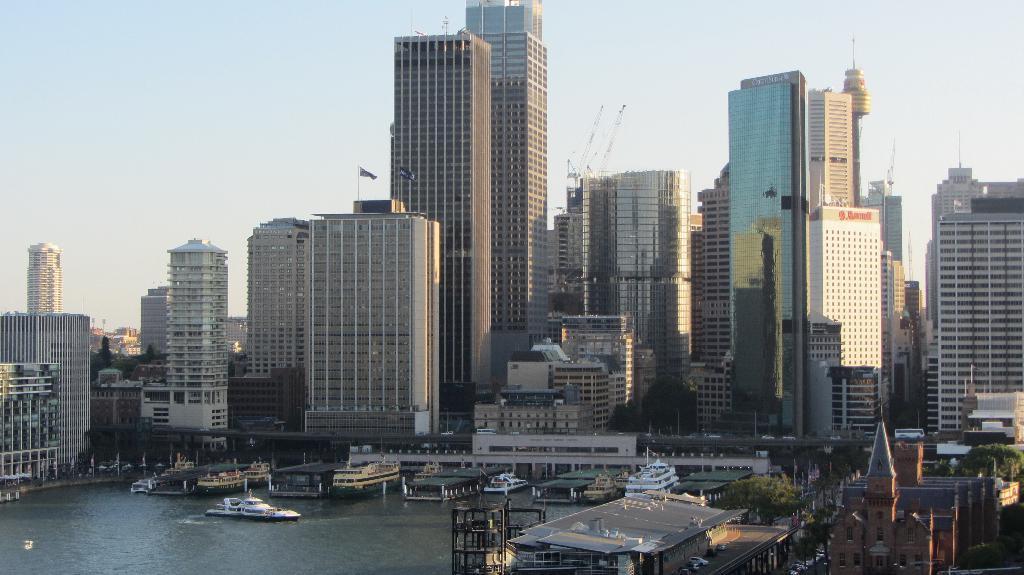How would you summarize this image in a sentence or two? In this image we can see many buildings. We can also see the trees, vehicles and also the ships on the surface of the water. We can also see the flags. Sky is also visible in this image. 